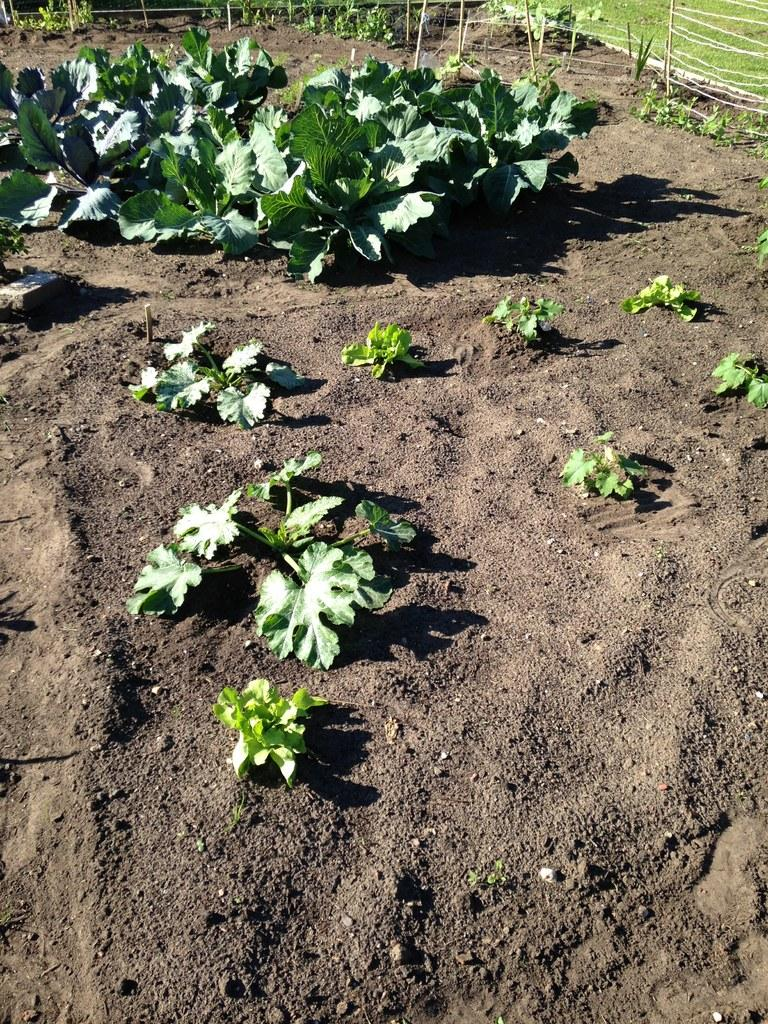What type of vegetation is present on the ground in the image? There are plants on the ground in the image. What can be seen in the background of the image? There is a fence in the background of the image. What type of quiver is visible on the fence in the image? There is no quiver present in the image; it only features plants on the ground and a fence in the background. 